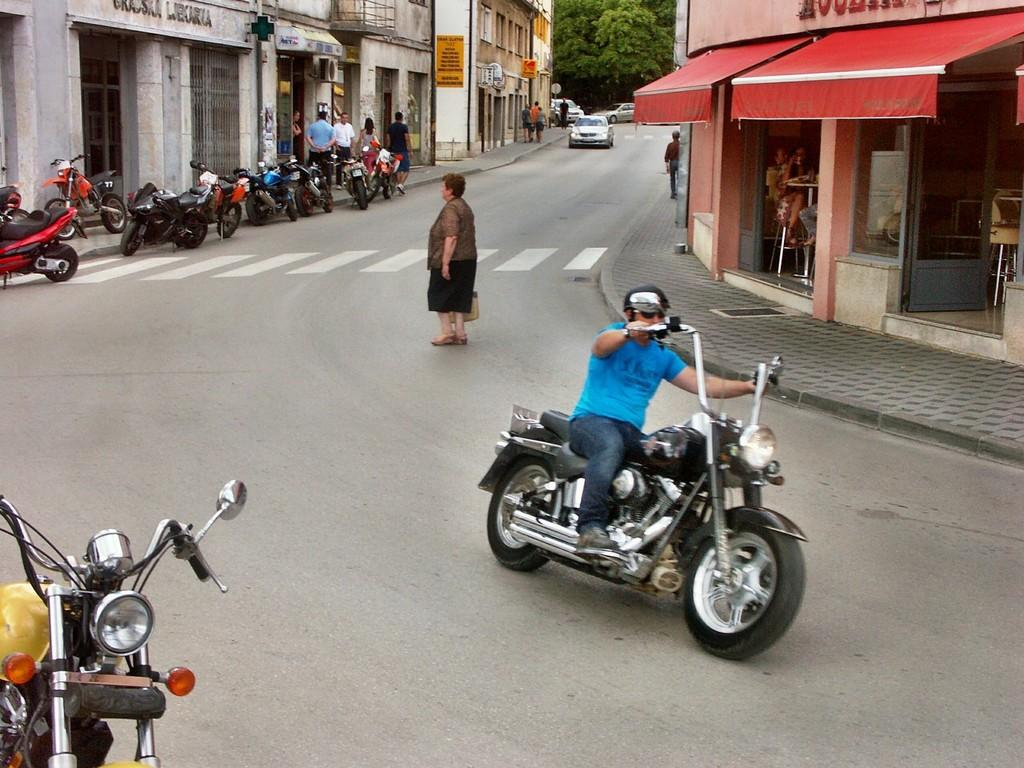What is the person in the image wearing? The person in the image is wearing a blue shirt. What activity is the person in the image engaged in? The person is riding a bike. What can be seen on the left side in the background of the image? There are parked bikes on the left side in the background. What is happening in the image involving another person? A woman is crossing the road in the image. What type of agreement is being discussed between the person and the deer in the image? There is no deer present in the image, so no agreement can be discussed between the person and a deer. 